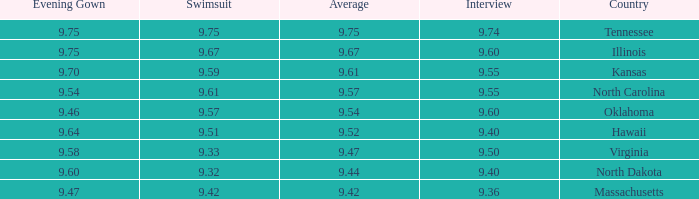What was the interview score for Hawaii? 9.4. 